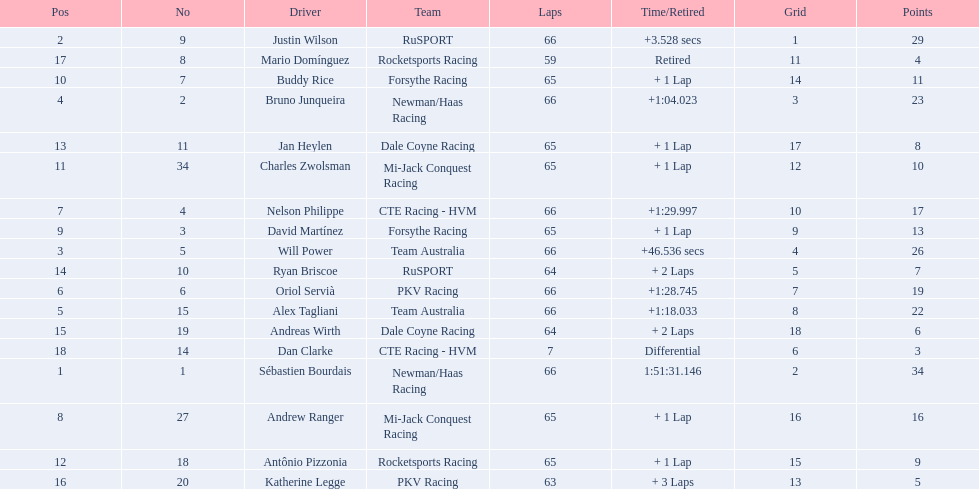Which teams participated in the 2006 gran premio telmex? Newman/Haas Racing, RuSPORT, Team Australia, Newman/Haas Racing, Team Australia, PKV Racing, CTE Racing - HVM, Mi-Jack Conquest Racing, Forsythe Racing, Forsythe Racing, Mi-Jack Conquest Racing, Rocketsports Racing, Dale Coyne Racing, RuSPORT, Dale Coyne Racing, PKV Racing, Rocketsports Racing, CTE Racing - HVM. Who were the drivers of these teams? Sébastien Bourdais, Justin Wilson, Will Power, Bruno Junqueira, Alex Tagliani, Oriol Servià, Nelson Philippe, Andrew Ranger, David Martínez, Buddy Rice, Charles Zwolsman, Antônio Pizzonia, Jan Heylen, Ryan Briscoe, Andreas Wirth, Katherine Legge, Mario Domínguez, Dan Clarke. Which driver finished last? Dan Clarke. 